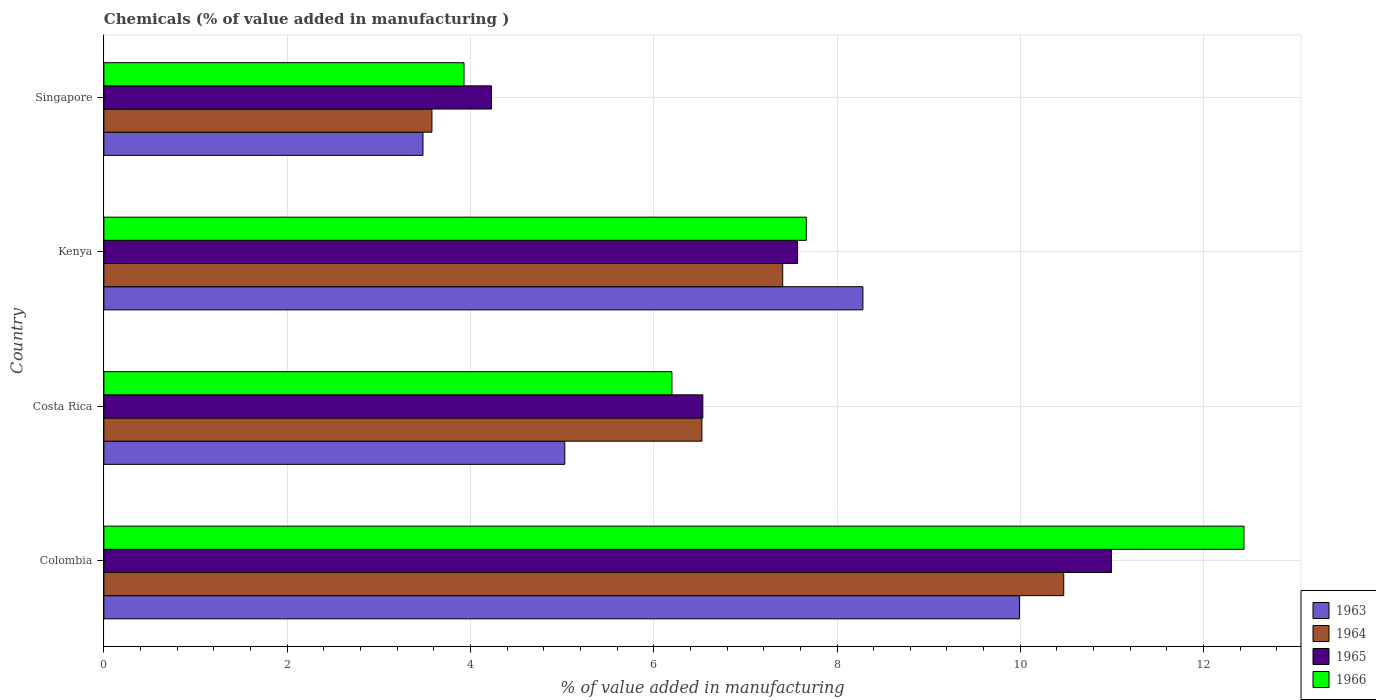How many different coloured bars are there?
Make the answer very short. 4. Are the number of bars per tick equal to the number of legend labels?
Offer a very short reply. Yes. What is the label of the 4th group of bars from the top?
Your answer should be very brief. Colombia. What is the value added in manufacturing chemicals in 1965 in Costa Rica?
Your answer should be very brief. 6.54. Across all countries, what is the maximum value added in manufacturing chemicals in 1963?
Give a very brief answer. 9.99. Across all countries, what is the minimum value added in manufacturing chemicals in 1965?
Your answer should be very brief. 4.23. In which country was the value added in manufacturing chemicals in 1963 maximum?
Provide a succinct answer. Colombia. In which country was the value added in manufacturing chemicals in 1963 minimum?
Provide a succinct answer. Singapore. What is the total value added in manufacturing chemicals in 1965 in the graph?
Give a very brief answer. 29.33. What is the difference between the value added in manufacturing chemicals in 1963 in Colombia and that in Singapore?
Provide a short and direct response. 6.51. What is the difference between the value added in manufacturing chemicals in 1963 in Colombia and the value added in manufacturing chemicals in 1966 in Singapore?
Give a very brief answer. 6.06. What is the average value added in manufacturing chemicals in 1965 per country?
Provide a succinct answer. 7.33. What is the difference between the value added in manufacturing chemicals in 1966 and value added in manufacturing chemicals in 1965 in Costa Rica?
Your answer should be very brief. -0.34. In how many countries, is the value added in manufacturing chemicals in 1964 greater than 8.4 %?
Your answer should be very brief. 1. What is the ratio of the value added in manufacturing chemicals in 1965 in Colombia to that in Kenya?
Give a very brief answer. 1.45. What is the difference between the highest and the second highest value added in manufacturing chemicals in 1964?
Offer a very short reply. 3.07. What is the difference between the highest and the lowest value added in manufacturing chemicals in 1964?
Give a very brief answer. 6.89. Is the sum of the value added in manufacturing chemicals in 1963 in Colombia and Kenya greater than the maximum value added in manufacturing chemicals in 1964 across all countries?
Your answer should be very brief. Yes. What does the 4th bar from the bottom in Costa Rica represents?
Give a very brief answer. 1966. Is it the case that in every country, the sum of the value added in manufacturing chemicals in 1963 and value added in manufacturing chemicals in 1964 is greater than the value added in manufacturing chemicals in 1966?
Ensure brevity in your answer.  Yes. Does the graph contain grids?
Make the answer very short. Yes. How are the legend labels stacked?
Make the answer very short. Vertical. What is the title of the graph?
Your response must be concise. Chemicals (% of value added in manufacturing ). What is the label or title of the X-axis?
Your answer should be compact. % of value added in manufacturing. What is the label or title of the Y-axis?
Make the answer very short. Country. What is the % of value added in manufacturing of 1963 in Colombia?
Offer a very short reply. 9.99. What is the % of value added in manufacturing of 1964 in Colombia?
Your answer should be compact. 10.47. What is the % of value added in manufacturing of 1965 in Colombia?
Provide a succinct answer. 10.99. What is the % of value added in manufacturing in 1966 in Colombia?
Make the answer very short. 12.44. What is the % of value added in manufacturing of 1963 in Costa Rica?
Ensure brevity in your answer.  5.03. What is the % of value added in manufacturing in 1964 in Costa Rica?
Ensure brevity in your answer.  6.53. What is the % of value added in manufacturing in 1965 in Costa Rica?
Give a very brief answer. 6.54. What is the % of value added in manufacturing of 1966 in Costa Rica?
Keep it short and to the point. 6.2. What is the % of value added in manufacturing in 1963 in Kenya?
Provide a succinct answer. 8.28. What is the % of value added in manufacturing in 1964 in Kenya?
Your answer should be compact. 7.41. What is the % of value added in manufacturing of 1965 in Kenya?
Ensure brevity in your answer.  7.57. What is the % of value added in manufacturing in 1966 in Kenya?
Your answer should be very brief. 7.67. What is the % of value added in manufacturing of 1963 in Singapore?
Give a very brief answer. 3.48. What is the % of value added in manufacturing of 1964 in Singapore?
Provide a short and direct response. 3.58. What is the % of value added in manufacturing in 1965 in Singapore?
Provide a short and direct response. 4.23. What is the % of value added in manufacturing in 1966 in Singapore?
Give a very brief answer. 3.93. Across all countries, what is the maximum % of value added in manufacturing of 1963?
Offer a terse response. 9.99. Across all countries, what is the maximum % of value added in manufacturing of 1964?
Offer a very short reply. 10.47. Across all countries, what is the maximum % of value added in manufacturing in 1965?
Keep it short and to the point. 10.99. Across all countries, what is the maximum % of value added in manufacturing of 1966?
Make the answer very short. 12.44. Across all countries, what is the minimum % of value added in manufacturing of 1963?
Provide a short and direct response. 3.48. Across all countries, what is the minimum % of value added in manufacturing in 1964?
Give a very brief answer. 3.58. Across all countries, what is the minimum % of value added in manufacturing in 1965?
Your answer should be very brief. 4.23. Across all countries, what is the minimum % of value added in manufacturing in 1966?
Your response must be concise. 3.93. What is the total % of value added in manufacturing in 1963 in the graph?
Give a very brief answer. 26.79. What is the total % of value added in manufacturing of 1964 in the graph?
Make the answer very short. 27.99. What is the total % of value added in manufacturing of 1965 in the graph?
Make the answer very short. 29.33. What is the total % of value added in manufacturing in 1966 in the graph?
Your answer should be very brief. 30.23. What is the difference between the % of value added in manufacturing in 1963 in Colombia and that in Costa Rica?
Your answer should be very brief. 4.96. What is the difference between the % of value added in manufacturing of 1964 in Colombia and that in Costa Rica?
Your answer should be compact. 3.95. What is the difference between the % of value added in manufacturing in 1965 in Colombia and that in Costa Rica?
Provide a short and direct response. 4.46. What is the difference between the % of value added in manufacturing in 1966 in Colombia and that in Costa Rica?
Keep it short and to the point. 6.24. What is the difference between the % of value added in manufacturing in 1963 in Colombia and that in Kenya?
Offer a very short reply. 1.71. What is the difference between the % of value added in manufacturing in 1964 in Colombia and that in Kenya?
Your answer should be compact. 3.07. What is the difference between the % of value added in manufacturing in 1965 in Colombia and that in Kenya?
Offer a terse response. 3.43. What is the difference between the % of value added in manufacturing of 1966 in Colombia and that in Kenya?
Your response must be concise. 4.78. What is the difference between the % of value added in manufacturing in 1963 in Colombia and that in Singapore?
Your answer should be very brief. 6.51. What is the difference between the % of value added in manufacturing of 1964 in Colombia and that in Singapore?
Your response must be concise. 6.89. What is the difference between the % of value added in manufacturing in 1965 in Colombia and that in Singapore?
Give a very brief answer. 6.76. What is the difference between the % of value added in manufacturing in 1966 in Colombia and that in Singapore?
Keep it short and to the point. 8.51. What is the difference between the % of value added in manufacturing of 1963 in Costa Rica and that in Kenya?
Give a very brief answer. -3.25. What is the difference between the % of value added in manufacturing of 1964 in Costa Rica and that in Kenya?
Make the answer very short. -0.88. What is the difference between the % of value added in manufacturing of 1965 in Costa Rica and that in Kenya?
Provide a short and direct response. -1.03. What is the difference between the % of value added in manufacturing of 1966 in Costa Rica and that in Kenya?
Provide a short and direct response. -1.47. What is the difference between the % of value added in manufacturing of 1963 in Costa Rica and that in Singapore?
Offer a terse response. 1.55. What is the difference between the % of value added in manufacturing of 1964 in Costa Rica and that in Singapore?
Ensure brevity in your answer.  2.95. What is the difference between the % of value added in manufacturing in 1965 in Costa Rica and that in Singapore?
Keep it short and to the point. 2.31. What is the difference between the % of value added in manufacturing in 1966 in Costa Rica and that in Singapore?
Give a very brief answer. 2.27. What is the difference between the % of value added in manufacturing in 1963 in Kenya and that in Singapore?
Provide a succinct answer. 4.8. What is the difference between the % of value added in manufacturing of 1964 in Kenya and that in Singapore?
Offer a very short reply. 3.83. What is the difference between the % of value added in manufacturing of 1965 in Kenya and that in Singapore?
Your answer should be compact. 3.34. What is the difference between the % of value added in manufacturing of 1966 in Kenya and that in Singapore?
Provide a succinct answer. 3.74. What is the difference between the % of value added in manufacturing in 1963 in Colombia and the % of value added in manufacturing in 1964 in Costa Rica?
Offer a very short reply. 3.47. What is the difference between the % of value added in manufacturing in 1963 in Colombia and the % of value added in manufacturing in 1965 in Costa Rica?
Keep it short and to the point. 3.46. What is the difference between the % of value added in manufacturing of 1963 in Colombia and the % of value added in manufacturing of 1966 in Costa Rica?
Your response must be concise. 3.79. What is the difference between the % of value added in manufacturing in 1964 in Colombia and the % of value added in manufacturing in 1965 in Costa Rica?
Your answer should be compact. 3.94. What is the difference between the % of value added in manufacturing in 1964 in Colombia and the % of value added in manufacturing in 1966 in Costa Rica?
Your response must be concise. 4.28. What is the difference between the % of value added in manufacturing in 1965 in Colombia and the % of value added in manufacturing in 1966 in Costa Rica?
Give a very brief answer. 4.8. What is the difference between the % of value added in manufacturing of 1963 in Colombia and the % of value added in manufacturing of 1964 in Kenya?
Offer a terse response. 2.58. What is the difference between the % of value added in manufacturing of 1963 in Colombia and the % of value added in manufacturing of 1965 in Kenya?
Provide a short and direct response. 2.42. What is the difference between the % of value added in manufacturing in 1963 in Colombia and the % of value added in manufacturing in 1966 in Kenya?
Give a very brief answer. 2.33. What is the difference between the % of value added in manufacturing of 1964 in Colombia and the % of value added in manufacturing of 1965 in Kenya?
Your answer should be very brief. 2.9. What is the difference between the % of value added in manufacturing of 1964 in Colombia and the % of value added in manufacturing of 1966 in Kenya?
Give a very brief answer. 2.81. What is the difference between the % of value added in manufacturing in 1965 in Colombia and the % of value added in manufacturing in 1966 in Kenya?
Provide a short and direct response. 3.33. What is the difference between the % of value added in manufacturing of 1963 in Colombia and the % of value added in manufacturing of 1964 in Singapore?
Provide a short and direct response. 6.41. What is the difference between the % of value added in manufacturing in 1963 in Colombia and the % of value added in manufacturing in 1965 in Singapore?
Your response must be concise. 5.76. What is the difference between the % of value added in manufacturing of 1963 in Colombia and the % of value added in manufacturing of 1966 in Singapore?
Make the answer very short. 6.06. What is the difference between the % of value added in manufacturing of 1964 in Colombia and the % of value added in manufacturing of 1965 in Singapore?
Your answer should be compact. 6.24. What is the difference between the % of value added in manufacturing of 1964 in Colombia and the % of value added in manufacturing of 1966 in Singapore?
Make the answer very short. 6.54. What is the difference between the % of value added in manufacturing of 1965 in Colombia and the % of value added in manufacturing of 1966 in Singapore?
Keep it short and to the point. 7.07. What is the difference between the % of value added in manufacturing of 1963 in Costa Rica and the % of value added in manufacturing of 1964 in Kenya?
Provide a succinct answer. -2.38. What is the difference between the % of value added in manufacturing in 1963 in Costa Rica and the % of value added in manufacturing in 1965 in Kenya?
Your response must be concise. -2.54. What is the difference between the % of value added in manufacturing of 1963 in Costa Rica and the % of value added in manufacturing of 1966 in Kenya?
Provide a succinct answer. -2.64. What is the difference between the % of value added in manufacturing of 1964 in Costa Rica and the % of value added in manufacturing of 1965 in Kenya?
Your response must be concise. -1.04. What is the difference between the % of value added in manufacturing of 1964 in Costa Rica and the % of value added in manufacturing of 1966 in Kenya?
Offer a very short reply. -1.14. What is the difference between the % of value added in manufacturing of 1965 in Costa Rica and the % of value added in manufacturing of 1966 in Kenya?
Provide a succinct answer. -1.13. What is the difference between the % of value added in manufacturing of 1963 in Costa Rica and the % of value added in manufacturing of 1964 in Singapore?
Your answer should be very brief. 1.45. What is the difference between the % of value added in manufacturing in 1963 in Costa Rica and the % of value added in manufacturing in 1965 in Singapore?
Make the answer very short. 0.8. What is the difference between the % of value added in manufacturing of 1963 in Costa Rica and the % of value added in manufacturing of 1966 in Singapore?
Your answer should be very brief. 1.1. What is the difference between the % of value added in manufacturing in 1964 in Costa Rica and the % of value added in manufacturing in 1965 in Singapore?
Your answer should be compact. 2.3. What is the difference between the % of value added in manufacturing in 1964 in Costa Rica and the % of value added in manufacturing in 1966 in Singapore?
Ensure brevity in your answer.  2.6. What is the difference between the % of value added in manufacturing of 1965 in Costa Rica and the % of value added in manufacturing of 1966 in Singapore?
Keep it short and to the point. 2.61. What is the difference between the % of value added in manufacturing in 1963 in Kenya and the % of value added in manufacturing in 1964 in Singapore?
Offer a very short reply. 4.7. What is the difference between the % of value added in manufacturing in 1963 in Kenya and the % of value added in manufacturing in 1965 in Singapore?
Provide a short and direct response. 4.05. What is the difference between the % of value added in manufacturing of 1963 in Kenya and the % of value added in manufacturing of 1966 in Singapore?
Provide a short and direct response. 4.35. What is the difference between the % of value added in manufacturing of 1964 in Kenya and the % of value added in manufacturing of 1965 in Singapore?
Provide a succinct answer. 3.18. What is the difference between the % of value added in manufacturing in 1964 in Kenya and the % of value added in manufacturing in 1966 in Singapore?
Your response must be concise. 3.48. What is the difference between the % of value added in manufacturing in 1965 in Kenya and the % of value added in manufacturing in 1966 in Singapore?
Your answer should be compact. 3.64. What is the average % of value added in manufacturing in 1963 per country?
Your response must be concise. 6.7. What is the average % of value added in manufacturing in 1964 per country?
Make the answer very short. 7. What is the average % of value added in manufacturing of 1965 per country?
Your response must be concise. 7.33. What is the average % of value added in manufacturing of 1966 per country?
Offer a very short reply. 7.56. What is the difference between the % of value added in manufacturing of 1963 and % of value added in manufacturing of 1964 in Colombia?
Offer a terse response. -0.48. What is the difference between the % of value added in manufacturing in 1963 and % of value added in manufacturing in 1965 in Colombia?
Make the answer very short. -1. What is the difference between the % of value added in manufacturing in 1963 and % of value added in manufacturing in 1966 in Colombia?
Your answer should be compact. -2.45. What is the difference between the % of value added in manufacturing in 1964 and % of value added in manufacturing in 1965 in Colombia?
Ensure brevity in your answer.  -0.52. What is the difference between the % of value added in manufacturing in 1964 and % of value added in manufacturing in 1966 in Colombia?
Provide a succinct answer. -1.97. What is the difference between the % of value added in manufacturing in 1965 and % of value added in manufacturing in 1966 in Colombia?
Keep it short and to the point. -1.45. What is the difference between the % of value added in manufacturing in 1963 and % of value added in manufacturing in 1964 in Costa Rica?
Provide a succinct answer. -1.5. What is the difference between the % of value added in manufacturing in 1963 and % of value added in manufacturing in 1965 in Costa Rica?
Your answer should be compact. -1.51. What is the difference between the % of value added in manufacturing of 1963 and % of value added in manufacturing of 1966 in Costa Rica?
Your response must be concise. -1.17. What is the difference between the % of value added in manufacturing of 1964 and % of value added in manufacturing of 1965 in Costa Rica?
Provide a short and direct response. -0.01. What is the difference between the % of value added in manufacturing in 1964 and % of value added in manufacturing in 1966 in Costa Rica?
Make the answer very short. 0.33. What is the difference between the % of value added in manufacturing in 1965 and % of value added in manufacturing in 1966 in Costa Rica?
Ensure brevity in your answer.  0.34. What is the difference between the % of value added in manufacturing of 1963 and % of value added in manufacturing of 1964 in Kenya?
Your answer should be very brief. 0.87. What is the difference between the % of value added in manufacturing of 1963 and % of value added in manufacturing of 1965 in Kenya?
Provide a succinct answer. 0.71. What is the difference between the % of value added in manufacturing of 1963 and % of value added in manufacturing of 1966 in Kenya?
Provide a short and direct response. 0.62. What is the difference between the % of value added in manufacturing of 1964 and % of value added in manufacturing of 1965 in Kenya?
Offer a very short reply. -0.16. What is the difference between the % of value added in manufacturing of 1964 and % of value added in manufacturing of 1966 in Kenya?
Make the answer very short. -0.26. What is the difference between the % of value added in manufacturing of 1965 and % of value added in manufacturing of 1966 in Kenya?
Keep it short and to the point. -0.1. What is the difference between the % of value added in manufacturing of 1963 and % of value added in manufacturing of 1964 in Singapore?
Your response must be concise. -0.1. What is the difference between the % of value added in manufacturing of 1963 and % of value added in manufacturing of 1965 in Singapore?
Offer a very short reply. -0.75. What is the difference between the % of value added in manufacturing of 1963 and % of value added in manufacturing of 1966 in Singapore?
Provide a succinct answer. -0.45. What is the difference between the % of value added in manufacturing of 1964 and % of value added in manufacturing of 1965 in Singapore?
Make the answer very short. -0.65. What is the difference between the % of value added in manufacturing in 1964 and % of value added in manufacturing in 1966 in Singapore?
Provide a short and direct response. -0.35. What is the difference between the % of value added in manufacturing of 1965 and % of value added in manufacturing of 1966 in Singapore?
Ensure brevity in your answer.  0.3. What is the ratio of the % of value added in manufacturing in 1963 in Colombia to that in Costa Rica?
Ensure brevity in your answer.  1.99. What is the ratio of the % of value added in manufacturing in 1964 in Colombia to that in Costa Rica?
Your response must be concise. 1.61. What is the ratio of the % of value added in manufacturing of 1965 in Colombia to that in Costa Rica?
Offer a terse response. 1.68. What is the ratio of the % of value added in manufacturing in 1966 in Colombia to that in Costa Rica?
Keep it short and to the point. 2.01. What is the ratio of the % of value added in manufacturing in 1963 in Colombia to that in Kenya?
Offer a terse response. 1.21. What is the ratio of the % of value added in manufacturing of 1964 in Colombia to that in Kenya?
Provide a short and direct response. 1.41. What is the ratio of the % of value added in manufacturing of 1965 in Colombia to that in Kenya?
Ensure brevity in your answer.  1.45. What is the ratio of the % of value added in manufacturing of 1966 in Colombia to that in Kenya?
Provide a short and direct response. 1.62. What is the ratio of the % of value added in manufacturing of 1963 in Colombia to that in Singapore?
Offer a terse response. 2.87. What is the ratio of the % of value added in manufacturing of 1964 in Colombia to that in Singapore?
Your answer should be compact. 2.93. What is the ratio of the % of value added in manufacturing of 1965 in Colombia to that in Singapore?
Your response must be concise. 2.6. What is the ratio of the % of value added in manufacturing of 1966 in Colombia to that in Singapore?
Offer a very short reply. 3.17. What is the ratio of the % of value added in manufacturing in 1963 in Costa Rica to that in Kenya?
Your answer should be very brief. 0.61. What is the ratio of the % of value added in manufacturing in 1964 in Costa Rica to that in Kenya?
Give a very brief answer. 0.88. What is the ratio of the % of value added in manufacturing of 1965 in Costa Rica to that in Kenya?
Offer a terse response. 0.86. What is the ratio of the % of value added in manufacturing in 1966 in Costa Rica to that in Kenya?
Offer a terse response. 0.81. What is the ratio of the % of value added in manufacturing of 1963 in Costa Rica to that in Singapore?
Provide a succinct answer. 1.44. What is the ratio of the % of value added in manufacturing in 1964 in Costa Rica to that in Singapore?
Ensure brevity in your answer.  1.82. What is the ratio of the % of value added in manufacturing of 1965 in Costa Rica to that in Singapore?
Provide a short and direct response. 1.55. What is the ratio of the % of value added in manufacturing of 1966 in Costa Rica to that in Singapore?
Your response must be concise. 1.58. What is the ratio of the % of value added in manufacturing in 1963 in Kenya to that in Singapore?
Offer a terse response. 2.38. What is the ratio of the % of value added in manufacturing in 1964 in Kenya to that in Singapore?
Give a very brief answer. 2.07. What is the ratio of the % of value added in manufacturing in 1965 in Kenya to that in Singapore?
Provide a short and direct response. 1.79. What is the ratio of the % of value added in manufacturing in 1966 in Kenya to that in Singapore?
Give a very brief answer. 1.95. What is the difference between the highest and the second highest % of value added in manufacturing of 1963?
Your answer should be very brief. 1.71. What is the difference between the highest and the second highest % of value added in manufacturing of 1964?
Your answer should be compact. 3.07. What is the difference between the highest and the second highest % of value added in manufacturing in 1965?
Offer a terse response. 3.43. What is the difference between the highest and the second highest % of value added in manufacturing of 1966?
Make the answer very short. 4.78. What is the difference between the highest and the lowest % of value added in manufacturing of 1963?
Provide a short and direct response. 6.51. What is the difference between the highest and the lowest % of value added in manufacturing in 1964?
Your response must be concise. 6.89. What is the difference between the highest and the lowest % of value added in manufacturing of 1965?
Your answer should be compact. 6.76. What is the difference between the highest and the lowest % of value added in manufacturing in 1966?
Make the answer very short. 8.51. 